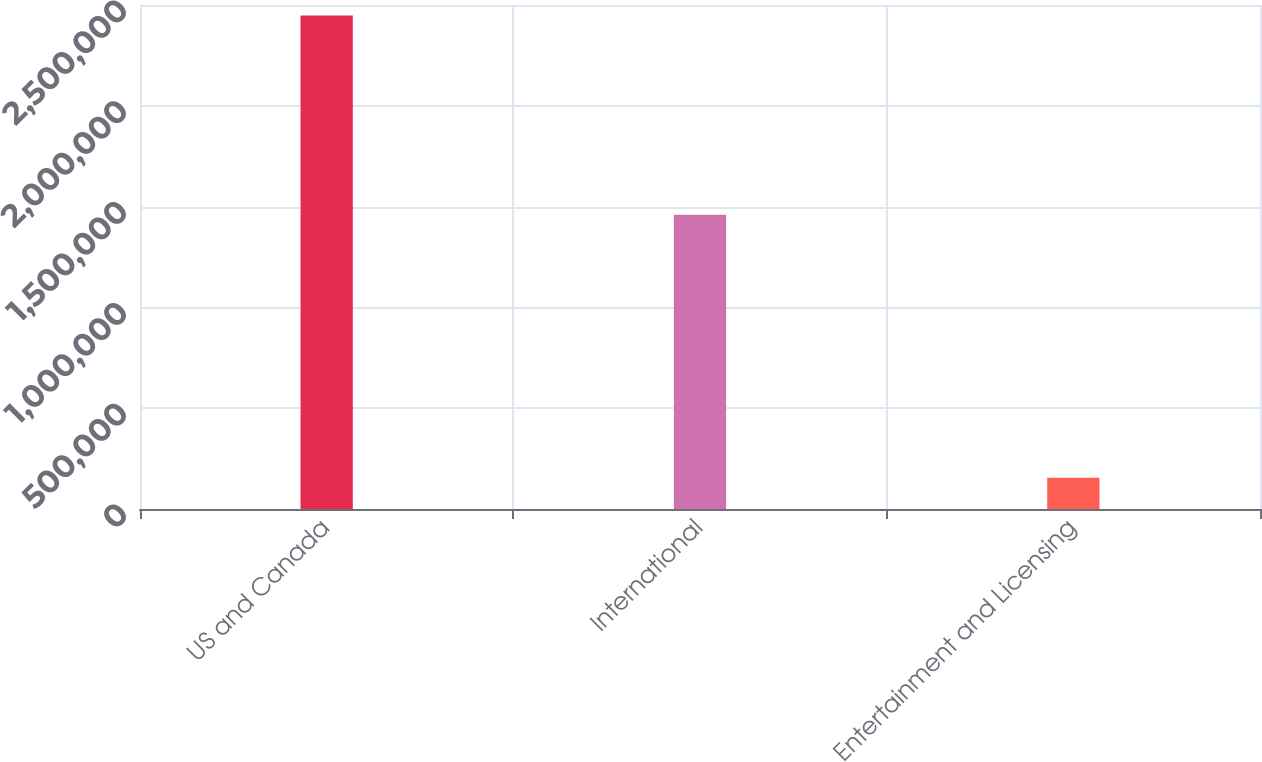Convert chart to OTSL. <chart><loc_0><loc_0><loc_500><loc_500><bar_chart><fcel>US and Canada<fcel>International<fcel>Entertainment and Licensing<nl><fcel>2.44794e+06<fcel>1.45948e+06<fcel>155013<nl></chart> 